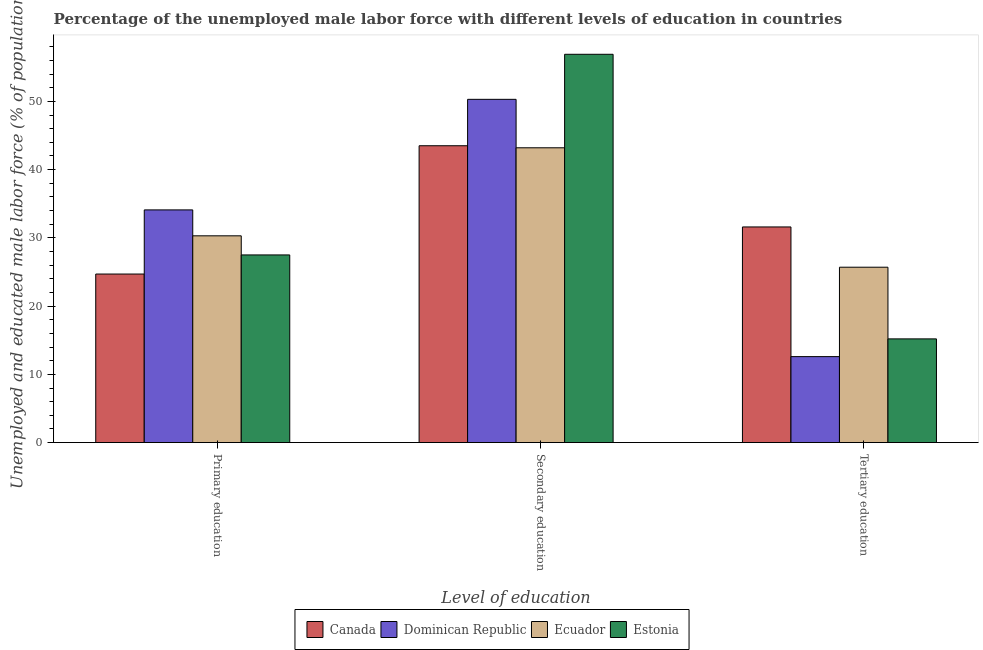How many bars are there on the 1st tick from the left?
Your answer should be very brief. 4. What is the label of the 2nd group of bars from the left?
Give a very brief answer. Secondary education. What is the percentage of male labor force who received secondary education in Canada?
Keep it short and to the point. 43.5. Across all countries, what is the maximum percentage of male labor force who received tertiary education?
Keep it short and to the point. 31.6. Across all countries, what is the minimum percentage of male labor force who received secondary education?
Offer a terse response. 43.2. In which country was the percentage of male labor force who received primary education maximum?
Your answer should be compact. Dominican Republic. What is the total percentage of male labor force who received tertiary education in the graph?
Provide a short and direct response. 85.1. What is the difference between the percentage of male labor force who received tertiary education in Estonia and that in Ecuador?
Your response must be concise. -10.5. What is the difference between the percentage of male labor force who received secondary education in Canada and the percentage of male labor force who received primary education in Dominican Republic?
Make the answer very short. 9.4. What is the average percentage of male labor force who received primary education per country?
Make the answer very short. 29.15. What is the difference between the percentage of male labor force who received tertiary education and percentage of male labor force who received secondary education in Canada?
Give a very brief answer. -11.9. In how many countries, is the percentage of male labor force who received secondary education greater than 4 %?
Provide a short and direct response. 4. What is the ratio of the percentage of male labor force who received primary education in Estonia to that in Canada?
Keep it short and to the point. 1.11. What is the difference between the highest and the second highest percentage of male labor force who received primary education?
Provide a short and direct response. 3.8. What is the difference between the highest and the lowest percentage of male labor force who received tertiary education?
Make the answer very short. 19. In how many countries, is the percentage of male labor force who received tertiary education greater than the average percentage of male labor force who received tertiary education taken over all countries?
Your answer should be compact. 2. Is the sum of the percentage of male labor force who received tertiary education in Canada and Ecuador greater than the maximum percentage of male labor force who received secondary education across all countries?
Ensure brevity in your answer.  Yes. What does the 4th bar from the left in Secondary education represents?
Provide a succinct answer. Estonia. What does the 4th bar from the right in Secondary education represents?
Your response must be concise. Canada. How many bars are there?
Provide a short and direct response. 12. Are all the bars in the graph horizontal?
Your response must be concise. No. What is the difference between two consecutive major ticks on the Y-axis?
Offer a terse response. 10. Are the values on the major ticks of Y-axis written in scientific E-notation?
Offer a very short reply. No. What is the title of the graph?
Give a very brief answer. Percentage of the unemployed male labor force with different levels of education in countries. Does "Isle of Man" appear as one of the legend labels in the graph?
Provide a short and direct response. No. What is the label or title of the X-axis?
Your response must be concise. Level of education. What is the label or title of the Y-axis?
Your answer should be very brief. Unemployed and educated male labor force (% of population). What is the Unemployed and educated male labor force (% of population) in Canada in Primary education?
Give a very brief answer. 24.7. What is the Unemployed and educated male labor force (% of population) of Dominican Republic in Primary education?
Ensure brevity in your answer.  34.1. What is the Unemployed and educated male labor force (% of population) in Ecuador in Primary education?
Ensure brevity in your answer.  30.3. What is the Unemployed and educated male labor force (% of population) in Estonia in Primary education?
Offer a very short reply. 27.5. What is the Unemployed and educated male labor force (% of population) in Canada in Secondary education?
Offer a very short reply. 43.5. What is the Unemployed and educated male labor force (% of population) in Dominican Republic in Secondary education?
Ensure brevity in your answer.  50.3. What is the Unemployed and educated male labor force (% of population) of Ecuador in Secondary education?
Offer a terse response. 43.2. What is the Unemployed and educated male labor force (% of population) in Estonia in Secondary education?
Provide a succinct answer. 56.9. What is the Unemployed and educated male labor force (% of population) of Canada in Tertiary education?
Give a very brief answer. 31.6. What is the Unemployed and educated male labor force (% of population) in Dominican Republic in Tertiary education?
Offer a very short reply. 12.6. What is the Unemployed and educated male labor force (% of population) of Ecuador in Tertiary education?
Give a very brief answer. 25.7. What is the Unemployed and educated male labor force (% of population) of Estonia in Tertiary education?
Your response must be concise. 15.2. Across all Level of education, what is the maximum Unemployed and educated male labor force (% of population) of Canada?
Your response must be concise. 43.5. Across all Level of education, what is the maximum Unemployed and educated male labor force (% of population) of Dominican Republic?
Keep it short and to the point. 50.3. Across all Level of education, what is the maximum Unemployed and educated male labor force (% of population) in Ecuador?
Give a very brief answer. 43.2. Across all Level of education, what is the maximum Unemployed and educated male labor force (% of population) of Estonia?
Provide a short and direct response. 56.9. Across all Level of education, what is the minimum Unemployed and educated male labor force (% of population) in Canada?
Offer a terse response. 24.7. Across all Level of education, what is the minimum Unemployed and educated male labor force (% of population) of Dominican Republic?
Keep it short and to the point. 12.6. Across all Level of education, what is the minimum Unemployed and educated male labor force (% of population) of Ecuador?
Keep it short and to the point. 25.7. Across all Level of education, what is the minimum Unemployed and educated male labor force (% of population) in Estonia?
Ensure brevity in your answer.  15.2. What is the total Unemployed and educated male labor force (% of population) in Canada in the graph?
Your answer should be compact. 99.8. What is the total Unemployed and educated male labor force (% of population) in Dominican Republic in the graph?
Your answer should be compact. 97. What is the total Unemployed and educated male labor force (% of population) in Ecuador in the graph?
Offer a terse response. 99.2. What is the total Unemployed and educated male labor force (% of population) in Estonia in the graph?
Give a very brief answer. 99.6. What is the difference between the Unemployed and educated male labor force (% of population) of Canada in Primary education and that in Secondary education?
Make the answer very short. -18.8. What is the difference between the Unemployed and educated male labor force (% of population) in Dominican Republic in Primary education and that in Secondary education?
Provide a succinct answer. -16.2. What is the difference between the Unemployed and educated male labor force (% of population) of Estonia in Primary education and that in Secondary education?
Your answer should be very brief. -29.4. What is the difference between the Unemployed and educated male labor force (% of population) of Dominican Republic in Primary education and that in Tertiary education?
Offer a terse response. 21.5. What is the difference between the Unemployed and educated male labor force (% of population) of Ecuador in Primary education and that in Tertiary education?
Your answer should be very brief. 4.6. What is the difference between the Unemployed and educated male labor force (% of population) in Dominican Republic in Secondary education and that in Tertiary education?
Provide a succinct answer. 37.7. What is the difference between the Unemployed and educated male labor force (% of population) of Ecuador in Secondary education and that in Tertiary education?
Provide a succinct answer. 17.5. What is the difference between the Unemployed and educated male labor force (% of population) of Estonia in Secondary education and that in Tertiary education?
Ensure brevity in your answer.  41.7. What is the difference between the Unemployed and educated male labor force (% of population) of Canada in Primary education and the Unemployed and educated male labor force (% of population) of Dominican Republic in Secondary education?
Provide a short and direct response. -25.6. What is the difference between the Unemployed and educated male labor force (% of population) of Canada in Primary education and the Unemployed and educated male labor force (% of population) of Ecuador in Secondary education?
Offer a very short reply. -18.5. What is the difference between the Unemployed and educated male labor force (% of population) of Canada in Primary education and the Unemployed and educated male labor force (% of population) of Estonia in Secondary education?
Make the answer very short. -32.2. What is the difference between the Unemployed and educated male labor force (% of population) in Dominican Republic in Primary education and the Unemployed and educated male labor force (% of population) in Ecuador in Secondary education?
Provide a short and direct response. -9.1. What is the difference between the Unemployed and educated male labor force (% of population) of Dominican Republic in Primary education and the Unemployed and educated male labor force (% of population) of Estonia in Secondary education?
Give a very brief answer. -22.8. What is the difference between the Unemployed and educated male labor force (% of population) in Ecuador in Primary education and the Unemployed and educated male labor force (% of population) in Estonia in Secondary education?
Keep it short and to the point. -26.6. What is the difference between the Unemployed and educated male labor force (% of population) in Canada in Primary education and the Unemployed and educated male labor force (% of population) in Ecuador in Tertiary education?
Your response must be concise. -1. What is the difference between the Unemployed and educated male labor force (% of population) of Dominican Republic in Primary education and the Unemployed and educated male labor force (% of population) of Ecuador in Tertiary education?
Offer a terse response. 8.4. What is the difference between the Unemployed and educated male labor force (% of population) of Ecuador in Primary education and the Unemployed and educated male labor force (% of population) of Estonia in Tertiary education?
Your response must be concise. 15.1. What is the difference between the Unemployed and educated male labor force (% of population) in Canada in Secondary education and the Unemployed and educated male labor force (% of population) in Dominican Republic in Tertiary education?
Offer a terse response. 30.9. What is the difference between the Unemployed and educated male labor force (% of population) in Canada in Secondary education and the Unemployed and educated male labor force (% of population) in Estonia in Tertiary education?
Offer a very short reply. 28.3. What is the difference between the Unemployed and educated male labor force (% of population) of Dominican Republic in Secondary education and the Unemployed and educated male labor force (% of population) of Ecuador in Tertiary education?
Your response must be concise. 24.6. What is the difference between the Unemployed and educated male labor force (% of population) of Dominican Republic in Secondary education and the Unemployed and educated male labor force (% of population) of Estonia in Tertiary education?
Provide a succinct answer. 35.1. What is the average Unemployed and educated male labor force (% of population) of Canada per Level of education?
Keep it short and to the point. 33.27. What is the average Unemployed and educated male labor force (% of population) of Dominican Republic per Level of education?
Your response must be concise. 32.33. What is the average Unemployed and educated male labor force (% of population) of Ecuador per Level of education?
Provide a succinct answer. 33.07. What is the average Unemployed and educated male labor force (% of population) in Estonia per Level of education?
Provide a succinct answer. 33.2. What is the difference between the Unemployed and educated male labor force (% of population) of Canada and Unemployed and educated male labor force (% of population) of Ecuador in Primary education?
Offer a terse response. -5.6. What is the difference between the Unemployed and educated male labor force (% of population) in Canada and Unemployed and educated male labor force (% of population) in Estonia in Primary education?
Your answer should be very brief. -2.8. What is the difference between the Unemployed and educated male labor force (% of population) of Canada and Unemployed and educated male labor force (% of population) of Ecuador in Secondary education?
Provide a succinct answer. 0.3. What is the difference between the Unemployed and educated male labor force (% of population) of Ecuador and Unemployed and educated male labor force (% of population) of Estonia in Secondary education?
Keep it short and to the point. -13.7. What is the difference between the Unemployed and educated male labor force (% of population) in Canada and Unemployed and educated male labor force (% of population) in Dominican Republic in Tertiary education?
Offer a terse response. 19. What is the difference between the Unemployed and educated male labor force (% of population) in Canada and Unemployed and educated male labor force (% of population) in Ecuador in Tertiary education?
Make the answer very short. 5.9. What is the ratio of the Unemployed and educated male labor force (% of population) in Canada in Primary education to that in Secondary education?
Make the answer very short. 0.57. What is the ratio of the Unemployed and educated male labor force (% of population) in Dominican Republic in Primary education to that in Secondary education?
Ensure brevity in your answer.  0.68. What is the ratio of the Unemployed and educated male labor force (% of population) of Ecuador in Primary education to that in Secondary education?
Give a very brief answer. 0.7. What is the ratio of the Unemployed and educated male labor force (% of population) of Estonia in Primary education to that in Secondary education?
Offer a terse response. 0.48. What is the ratio of the Unemployed and educated male labor force (% of population) of Canada in Primary education to that in Tertiary education?
Provide a short and direct response. 0.78. What is the ratio of the Unemployed and educated male labor force (% of population) in Dominican Republic in Primary education to that in Tertiary education?
Keep it short and to the point. 2.71. What is the ratio of the Unemployed and educated male labor force (% of population) in Ecuador in Primary education to that in Tertiary education?
Ensure brevity in your answer.  1.18. What is the ratio of the Unemployed and educated male labor force (% of population) of Estonia in Primary education to that in Tertiary education?
Provide a succinct answer. 1.81. What is the ratio of the Unemployed and educated male labor force (% of population) in Canada in Secondary education to that in Tertiary education?
Your answer should be compact. 1.38. What is the ratio of the Unemployed and educated male labor force (% of population) in Dominican Republic in Secondary education to that in Tertiary education?
Offer a terse response. 3.99. What is the ratio of the Unemployed and educated male labor force (% of population) in Ecuador in Secondary education to that in Tertiary education?
Your answer should be compact. 1.68. What is the ratio of the Unemployed and educated male labor force (% of population) in Estonia in Secondary education to that in Tertiary education?
Offer a terse response. 3.74. What is the difference between the highest and the second highest Unemployed and educated male labor force (% of population) of Estonia?
Provide a short and direct response. 29.4. What is the difference between the highest and the lowest Unemployed and educated male labor force (% of population) of Dominican Republic?
Provide a succinct answer. 37.7. What is the difference between the highest and the lowest Unemployed and educated male labor force (% of population) in Estonia?
Ensure brevity in your answer.  41.7. 